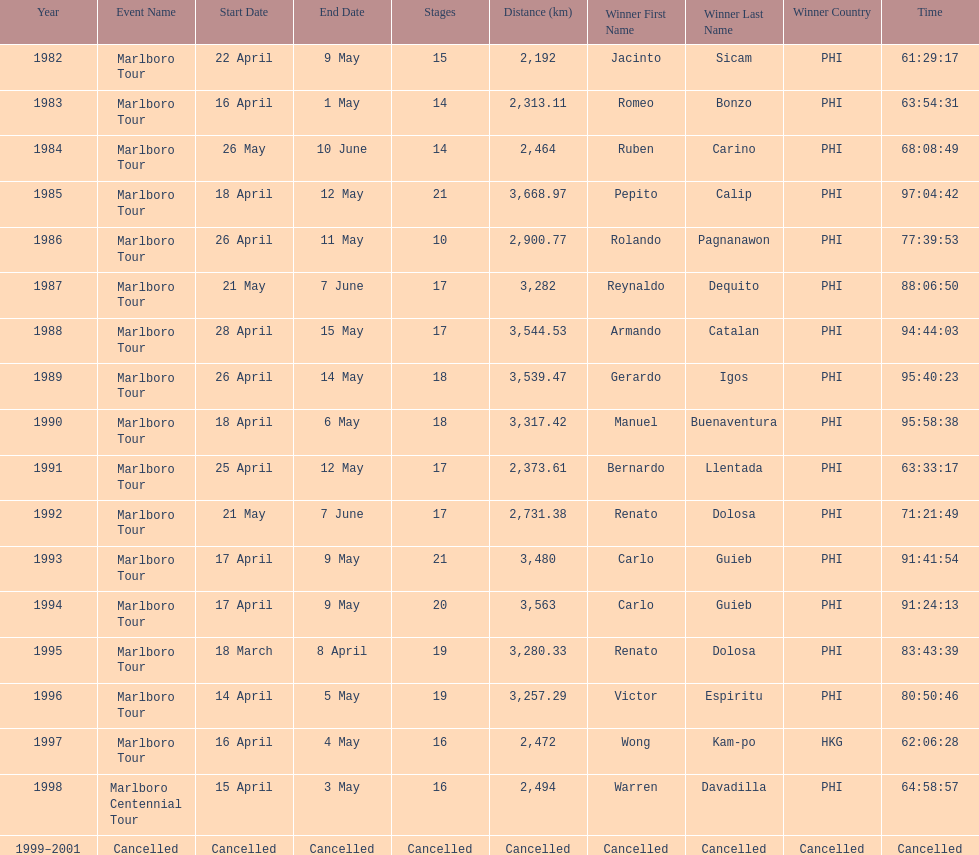How many stages was the 1982 marlboro tour? 15. 